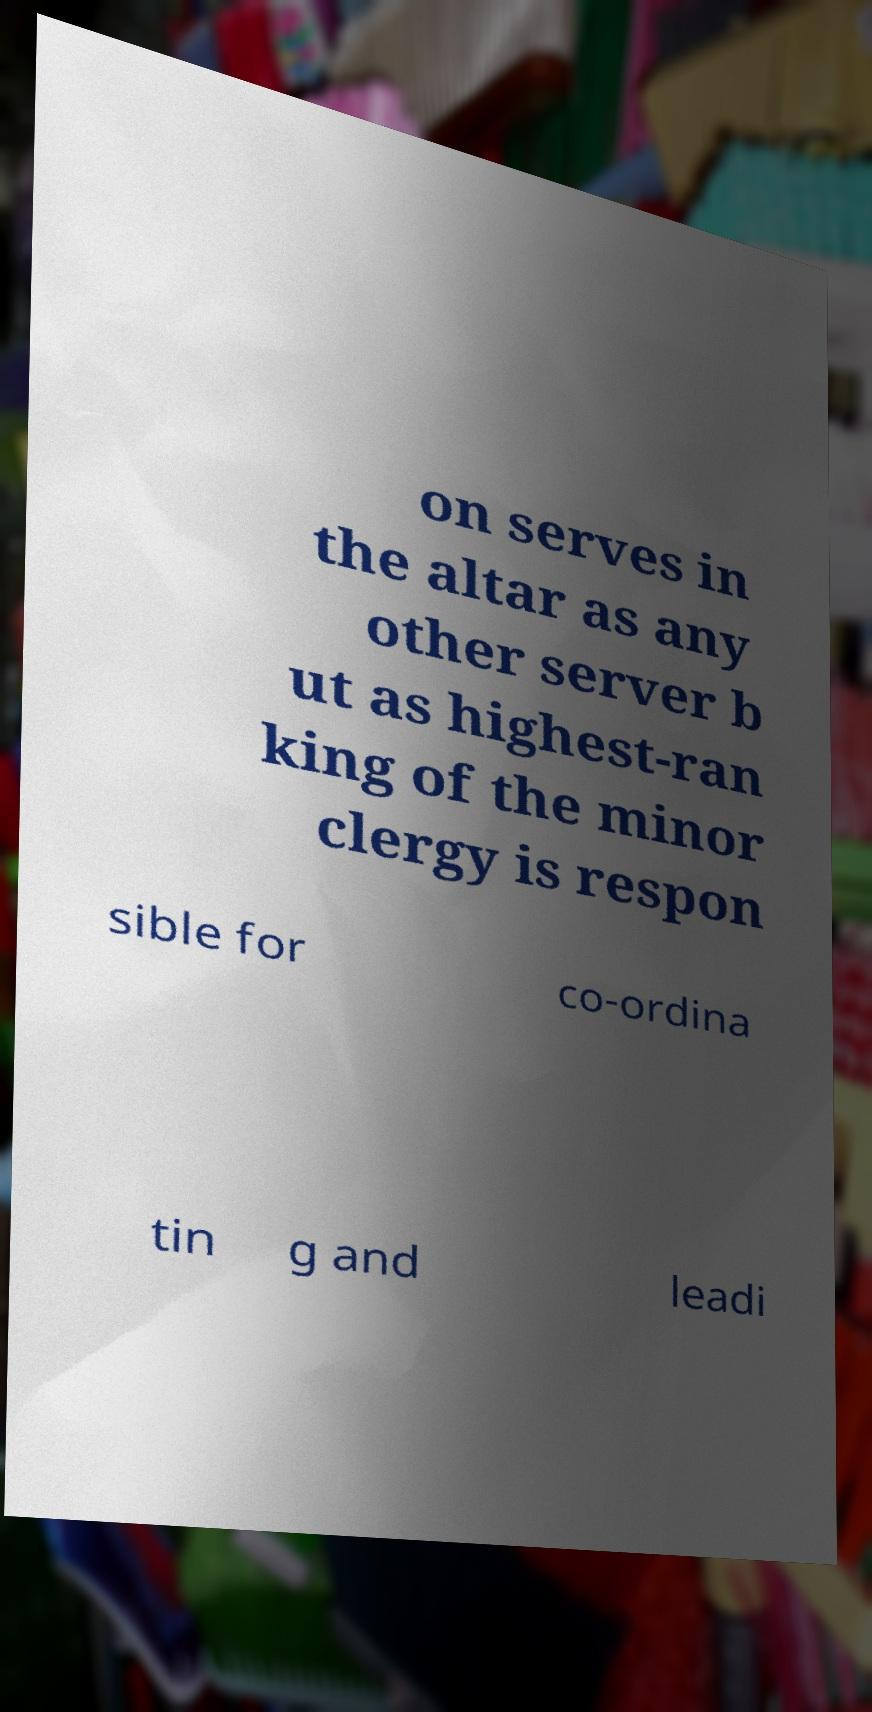Could you extract and type out the text from this image? on serves in the altar as any other server b ut as highest-ran king of the minor clergy is respon sible for co-ordina tin g and leadi 